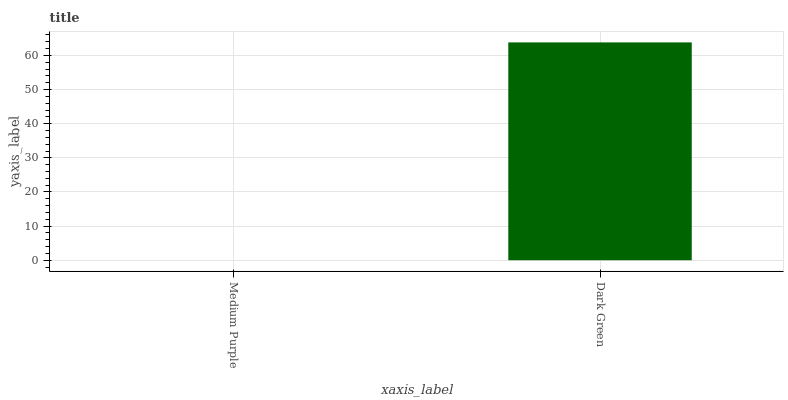Is Dark Green the minimum?
Answer yes or no. No. Is Dark Green greater than Medium Purple?
Answer yes or no. Yes. Is Medium Purple less than Dark Green?
Answer yes or no. Yes. Is Medium Purple greater than Dark Green?
Answer yes or no. No. Is Dark Green less than Medium Purple?
Answer yes or no. No. Is Dark Green the high median?
Answer yes or no. Yes. Is Medium Purple the low median?
Answer yes or no. Yes. Is Medium Purple the high median?
Answer yes or no. No. Is Dark Green the low median?
Answer yes or no. No. 